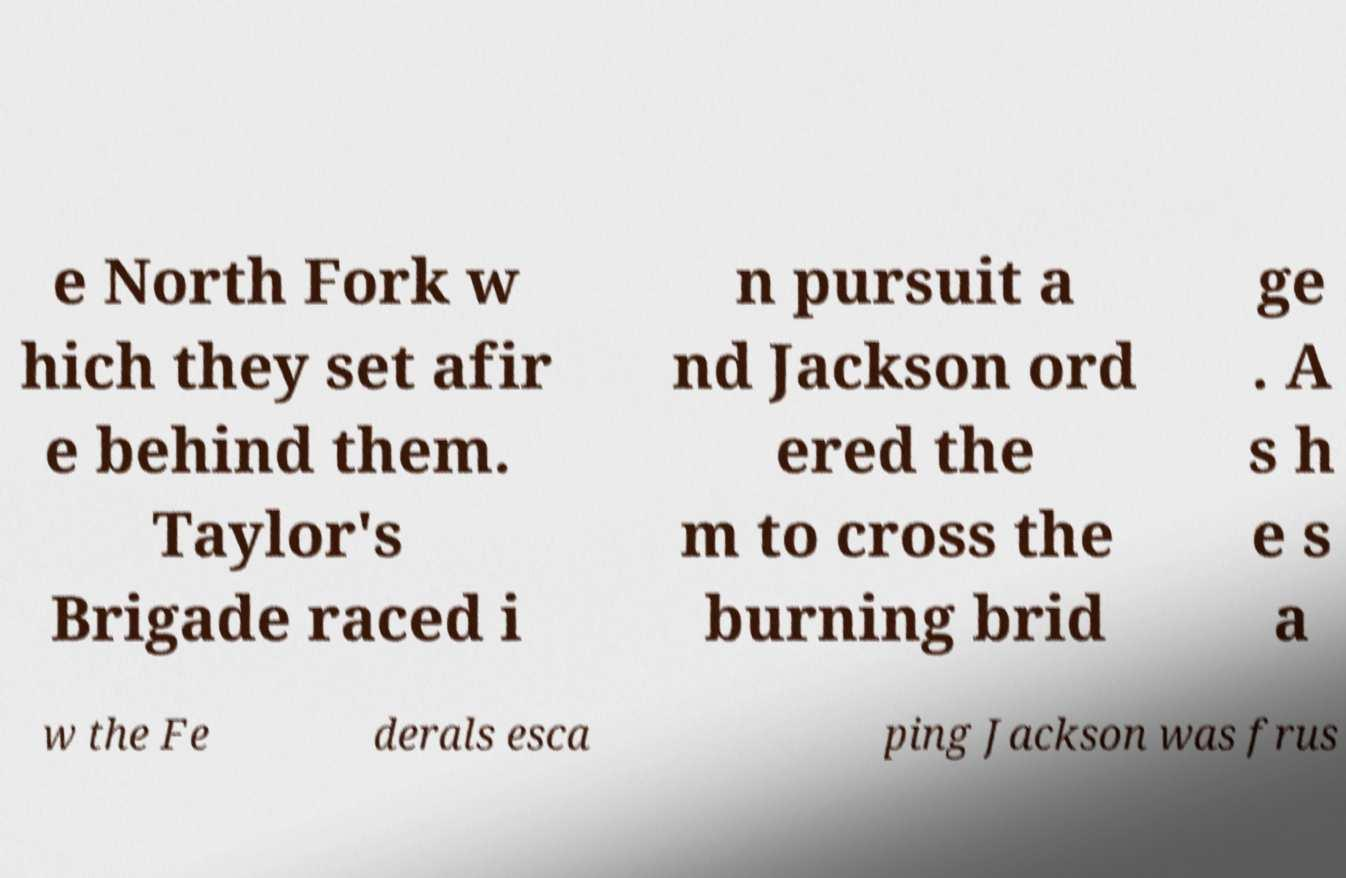Please read and relay the text visible in this image. What does it say? e North Fork w hich they set afir e behind them. Taylor's Brigade raced i n pursuit a nd Jackson ord ered the m to cross the burning brid ge . A s h e s a w the Fe derals esca ping Jackson was frus 